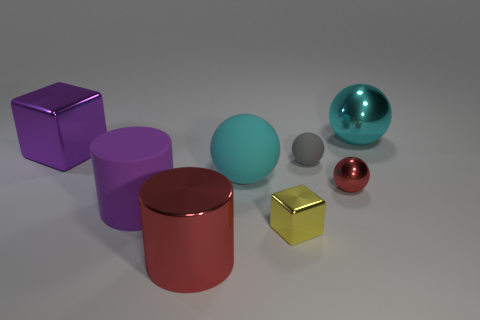Are there fewer small gray matte things than yellow rubber objects?
Give a very brief answer. No. What is the material of the sphere that is on the right side of the tiny gray object and in front of the purple shiny cube?
Your answer should be very brief. Metal. Are there any large things that are to the right of the block that is left of the metallic cylinder?
Make the answer very short. Yes. What number of objects are either matte spheres or large green metallic objects?
Your response must be concise. 2. What is the shape of the big object that is in front of the tiny red thing and on the right side of the matte cylinder?
Provide a succinct answer. Cylinder. Is the large thing that is on the right side of the gray matte ball made of the same material as the big purple cylinder?
Provide a short and direct response. No. What number of things are either cyan objects or objects that are in front of the gray object?
Your answer should be very brief. 6. What color is the tiny ball that is the same material as the red cylinder?
Your answer should be compact. Red. What number of big things are the same material as the red sphere?
Offer a very short reply. 3. What number of things are there?
Give a very brief answer. 8. 